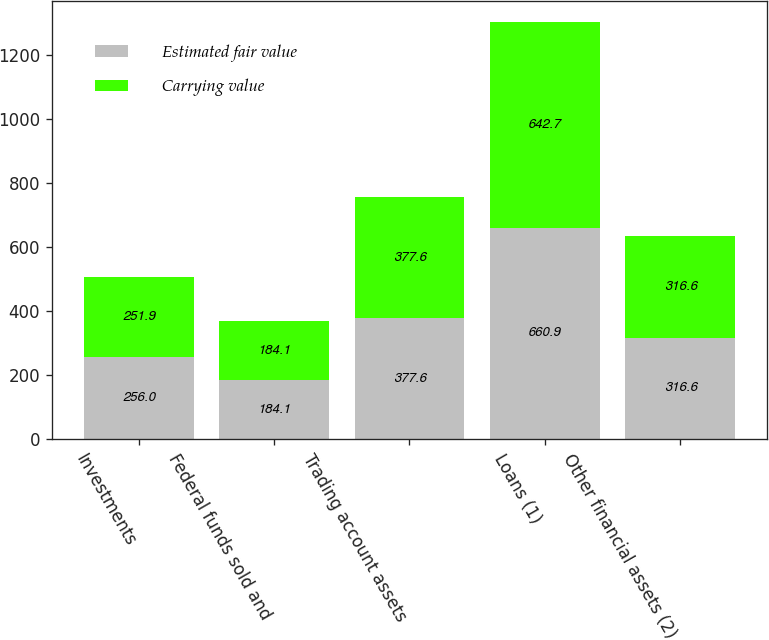<chart> <loc_0><loc_0><loc_500><loc_500><stacked_bar_chart><ecel><fcel>Investments<fcel>Federal funds sold and<fcel>Trading account assets<fcel>Loans (1)<fcel>Other financial assets (2)<nl><fcel>Estimated fair value<fcel>256<fcel>184.1<fcel>377.6<fcel>660.9<fcel>316.6<nl><fcel>Carrying value<fcel>251.9<fcel>184.1<fcel>377.6<fcel>642.7<fcel>316.6<nl></chart> 